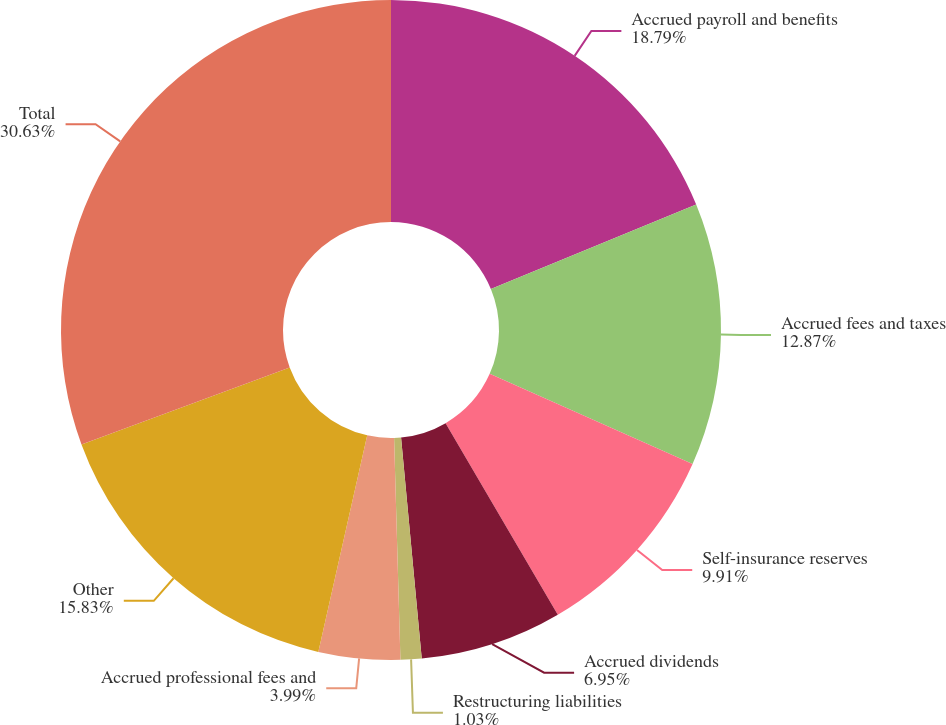<chart> <loc_0><loc_0><loc_500><loc_500><pie_chart><fcel>Accrued payroll and benefits<fcel>Accrued fees and taxes<fcel>Self-insurance reserves<fcel>Accrued dividends<fcel>Restructuring liabilities<fcel>Accrued professional fees and<fcel>Other<fcel>Total<nl><fcel>18.79%<fcel>12.87%<fcel>9.91%<fcel>6.95%<fcel>1.03%<fcel>3.99%<fcel>15.83%<fcel>30.64%<nl></chart> 